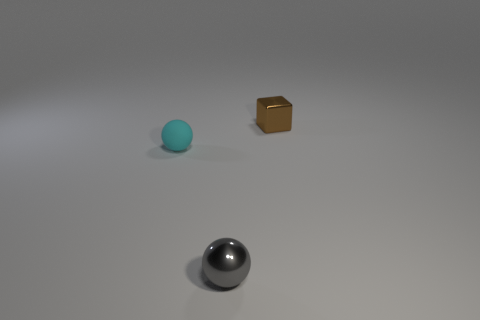Is the material of the small cyan ball the same as the brown block?
Offer a very short reply. No. What shape is the tiny metal object behind the tiny metallic object to the left of the small brown shiny block?
Provide a short and direct response. Cube. There is a small shiny object that is behind the cyan rubber object; how many gray shiny balls are behind it?
Provide a short and direct response. 0. What is the small thing that is right of the tiny cyan object and left of the tiny brown metal cube made of?
Make the answer very short. Metal. There is a brown object that is the same size as the cyan matte object; what shape is it?
Keep it short and to the point. Cube. There is a tiny thing that is behind the small object that is left of the sphere that is right of the cyan matte object; what is its color?
Give a very brief answer. Brown. What number of objects are cyan balls behind the small gray metallic thing or brown blocks?
Give a very brief answer. 2. There is a cyan object that is the same size as the gray metallic ball; what material is it?
Offer a terse response. Rubber. There is a tiny sphere that is to the right of the tiny sphere behind the tiny ball in front of the small cyan ball; what is it made of?
Give a very brief answer. Metal. The tiny metallic block has what color?
Give a very brief answer. Brown. 